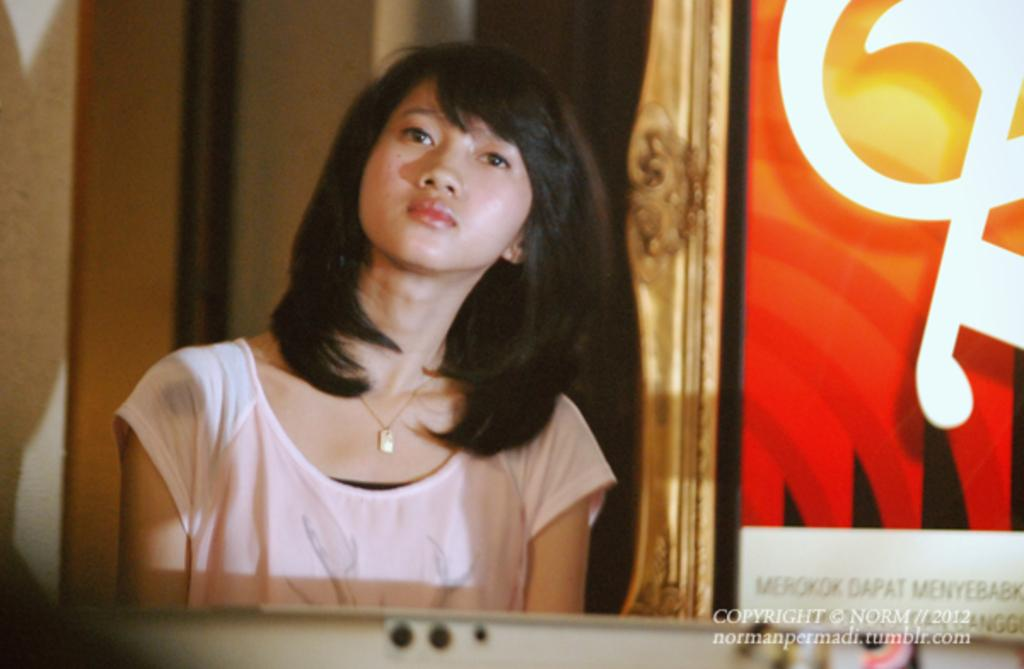Who is the main subject in the image? There is a girl in the image. What is the girl wearing? The girl is wearing a cream-colored T-shirt. Is there any text or marking on the image? Yes, there is a watermark in the bottom right side of the image. What is the relation between the girl and the cannon in the image? There is no cannon present in the image, so there is no relation between the girl and a cannon. 